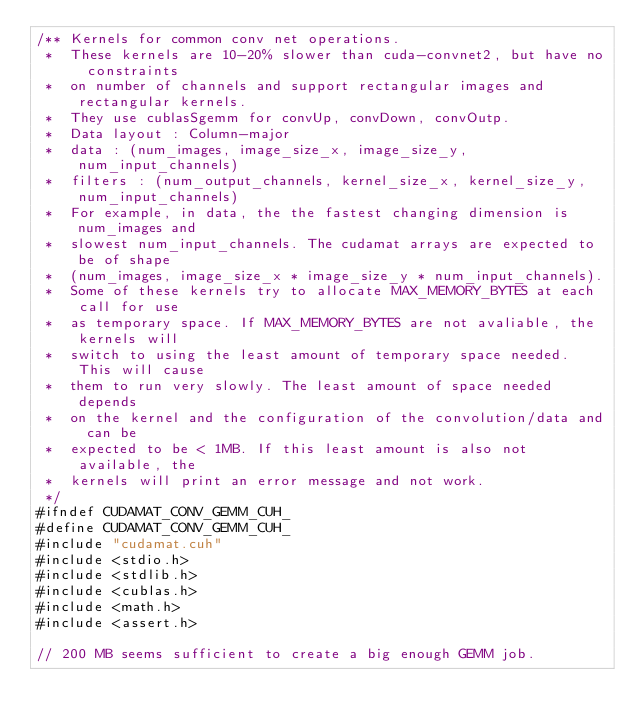Convert code to text. <code><loc_0><loc_0><loc_500><loc_500><_Cuda_>/** Kernels for common conv net operations.
 *  These kernels are 10-20% slower than cuda-convnet2, but have no constraints
 *  on number of channels and support rectangular images and rectangular kernels.
 *  They use cublasSgemm for convUp, convDown, convOutp.
 *  Data layout : Column-major
 *  data : (num_images, image_size_x, image_size_y, num_input_channels)
 *  filters : (num_output_channels, kernel_size_x, kernel_size_y, num_input_channels)
 *  For example, in data, the the fastest changing dimension is num_images and
 *  slowest num_input_channels. The cudamat arrays are expected to be of shape
 *  (num_images, image_size_x * image_size_y * num_input_channels).
 *  Some of these kernels try to allocate MAX_MEMORY_BYTES at each call for use
 *  as temporary space. If MAX_MEMORY_BYTES are not avaliable, the kernels will
 *  switch to using the least amount of temporary space needed. This will cause
 *  them to run very slowly. The least amount of space needed depends
 *  on the kernel and the configuration of the convolution/data and can be
 *  expected to be < 1MB. If this least amount is also not available, the
 *  kernels will print an error message and not work.
 */
#ifndef CUDAMAT_CONV_GEMM_CUH_
#define CUDAMAT_CONV_GEMM_CUH_
#include "cudamat.cuh"
#include <stdio.h>
#include <stdlib.h>
#include <cublas.h>
#include <math.h>
#include <assert.h>

// 200 MB seems sufficient to create a big enough GEMM job.</code> 